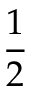Convert formula to latex. <formula><loc_0><loc_0><loc_500><loc_500>\frac { 1 } { 2 }</formula> 